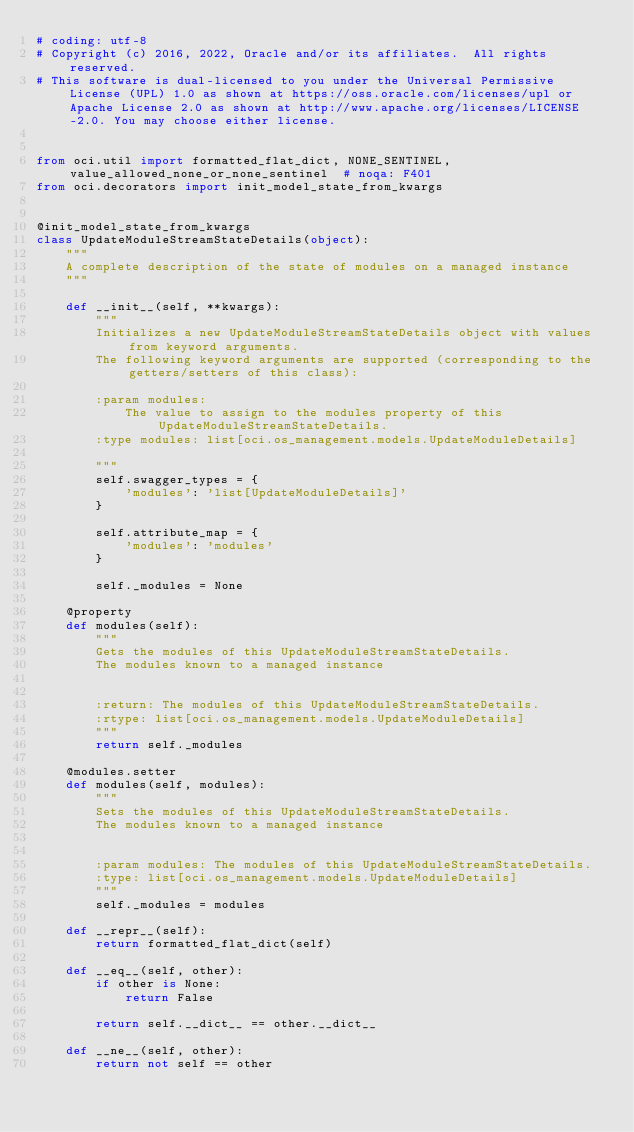Convert code to text. <code><loc_0><loc_0><loc_500><loc_500><_Python_># coding: utf-8
# Copyright (c) 2016, 2022, Oracle and/or its affiliates.  All rights reserved.
# This software is dual-licensed to you under the Universal Permissive License (UPL) 1.0 as shown at https://oss.oracle.com/licenses/upl or Apache License 2.0 as shown at http://www.apache.org/licenses/LICENSE-2.0. You may choose either license.


from oci.util import formatted_flat_dict, NONE_SENTINEL, value_allowed_none_or_none_sentinel  # noqa: F401
from oci.decorators import init_model_state_from_kwargs


@init_model_state_from_kwargs
class UpdateModuleStreamStateDetails(object):
    """
    A complete description of the state of modules on a managed instance
    """

    def __init__(self, **kwargs):
        """
        Initializes a new UpdateModuleStreamStateDetails object with values from keyword arguments.
        The following keyword arguments are supported (corresponding to the getters/setters of this class):

        :param modules:
            The value to assign to the modules property of this UpdateModuleStreamStateDetails.
        :type modules: list[oci.os_management.models.UpdateModuleDetails]

        """
        self.swagger_types = {
            'modules': 'list[UpdateModuleDetails]'
        }

        self.attribute_map = {
            'modules': 'modules'
        }

        self._modules = None

    @property
    def modules(self):
        """
        Gets the modules of this UpdateModuleStreamStateDetails.
        The modules known to a managed instance


        :return: The modules of this UpdateModuleStreamStateDetails.
        :rtype: list[oci.os_management.models.UpdateModuleDetails]
        """
        return self._modules

    @modules.setter
    def modules(self, modules):
        """
        Sets the modules of this UpdateModuleStreamStateDetails.
        The modules known to a managed instance


        :param modules: The modules of this UpdateModuleStreamStateDetails.
        :type: list[oci.os_management.models.UpdateModuleDetails]
        """
        self._modules = modules

    def __repr__(self):
        return formatted_flat_dict(self)

    def __eq__(self, other):
        if other is None:
            return False

        return self.__dict__ == other.__dict__

    def __ne__(self, other):
        return not self == other
</code> 